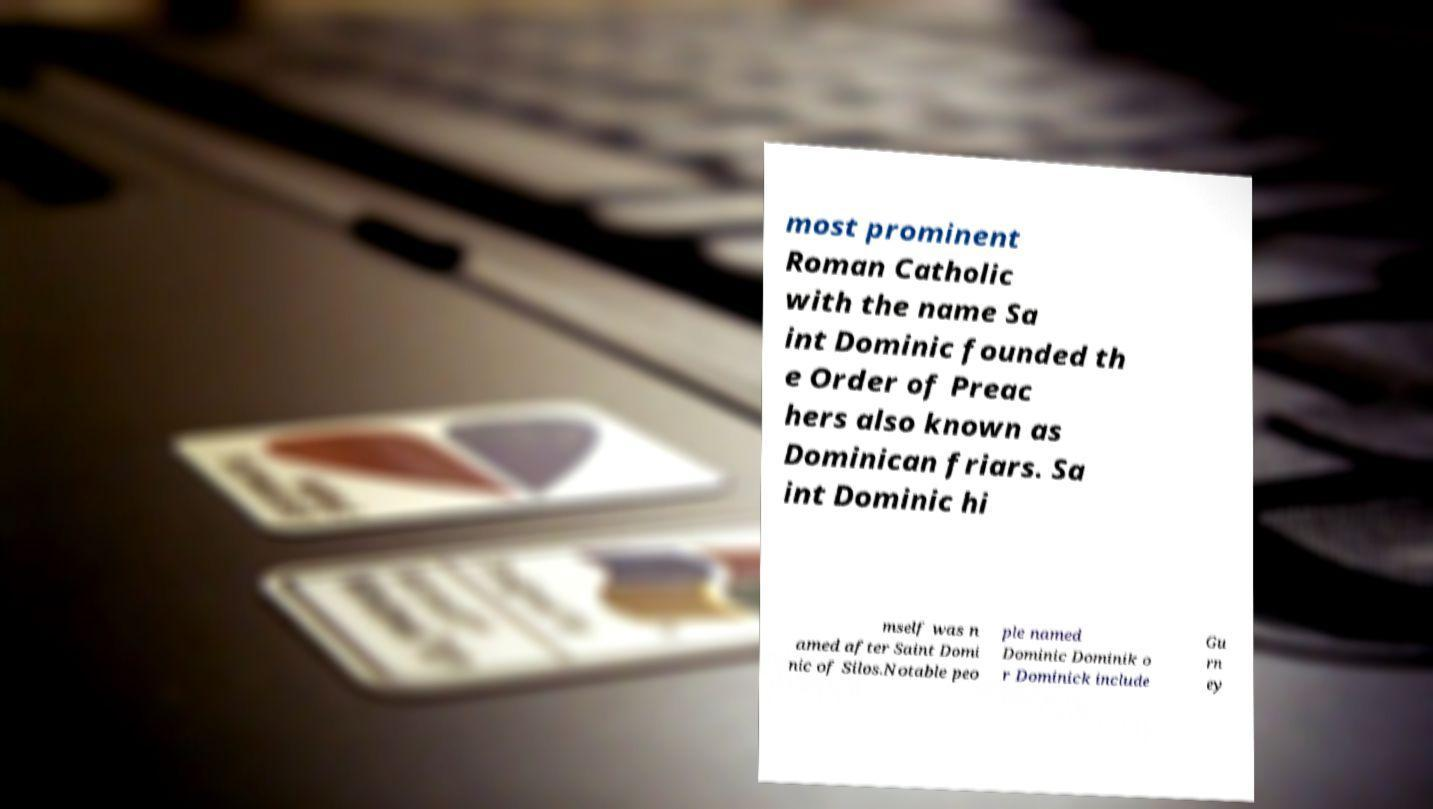Could you assist in decoding the text presented in this image and type it out clearly? most prominent Roman Catholic with the name Sa int Dominic founded th e Order of Preac hers also known as Dominican friars. Sa int Dominic hi mself was n amed after Saint Domi nic of Silos.Notable peo ple named Dominic Dominik o r Dominick include Gu rn ey 